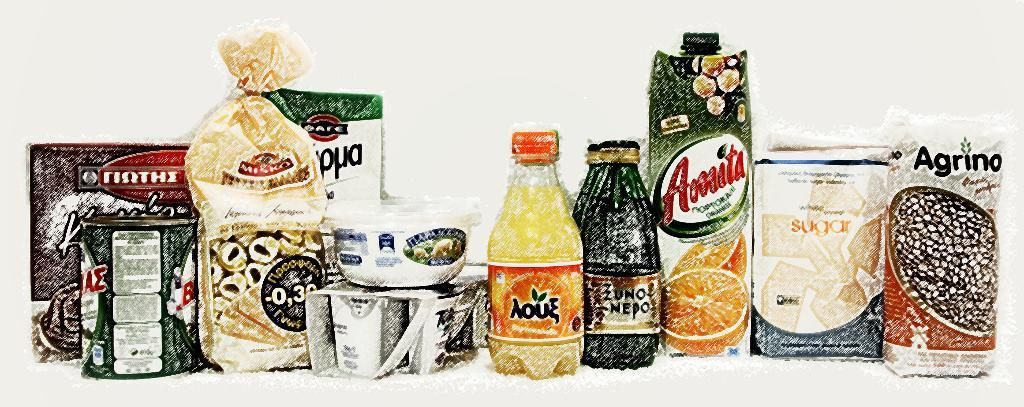<image>
Share a concise interpretation of the image provided. A selection of groceries including Amita orange juice carton. 